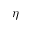<formula> <loc_0><loc_0><loc_500><loc_500>\eta</formula> 